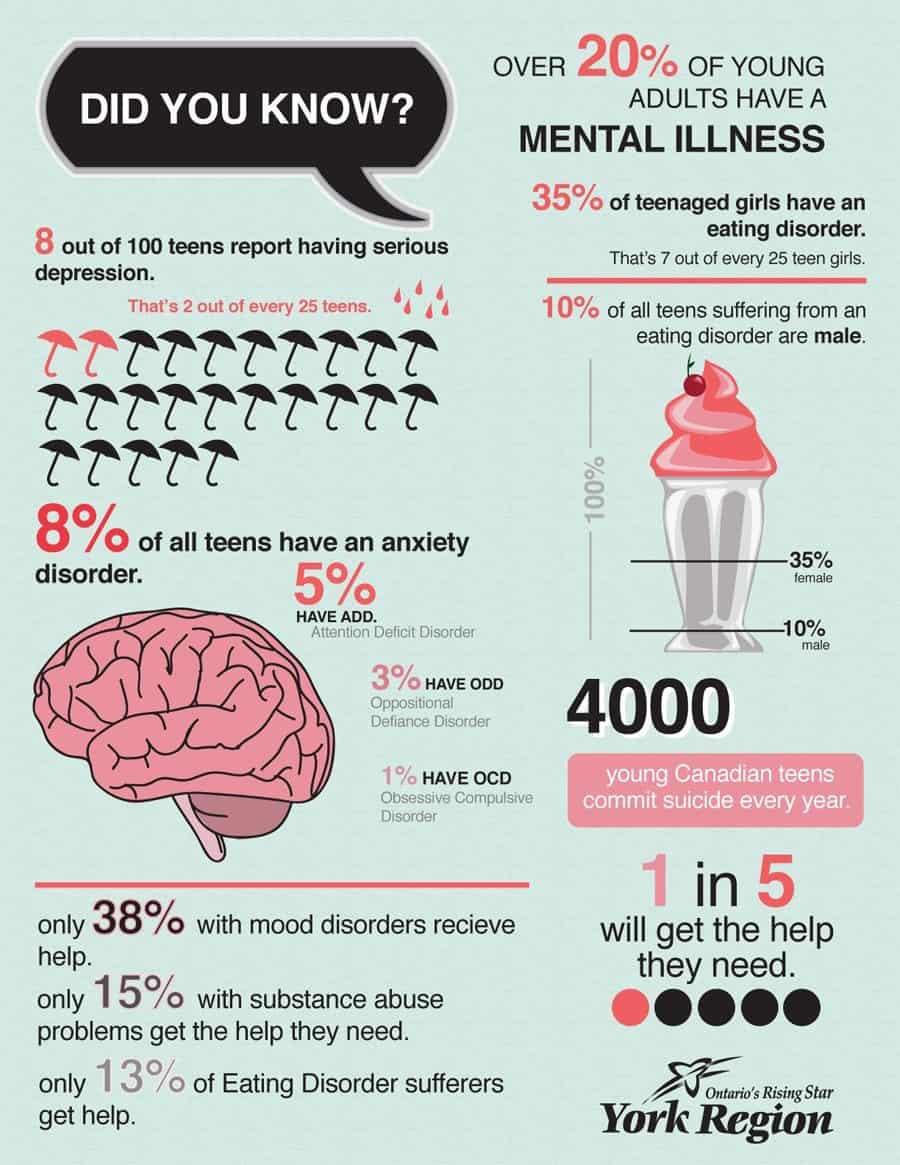List a handful of essential elements in this visual. It is estimated that approximately 99% of people do not have Obsessive Compulsive Disorder (OCD). In a recent survey, it was found that 62% of individuals with mood disorders do not seek help for their condition. Approximately 85% of individuals with substance abuse problems do not receive any form of help. It is more common to encounter ODD than ADD. There are two red umbrellas depicted in this infographic. 